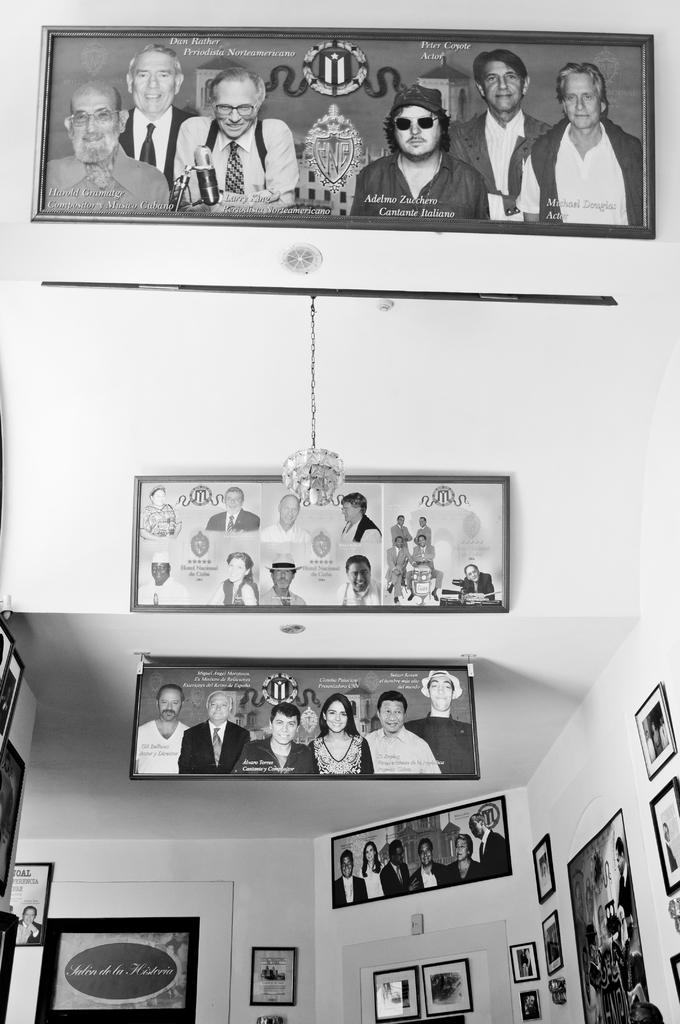Where is the setting of the image? The image appears to be inside a building. What can be seen on the walls in the image? There is a wall in the image, and photo frames are attached to it. Can you describe the lighting in the image? There is a light attached to a rod in the image. What type of attention is the fork receiving in the image? There is no fork present in the image, so it cannot receive any attention. 